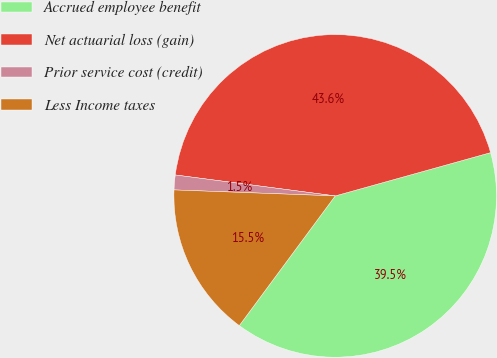Convert chart. <chart><loc_0><loc_0><loc_500><loc_500><pie_chart><fcel>Accrued employee benefit<fcel>Net actuarial loss (gain)<fcel>Prior service cost (credit)<fcel>Less Income taxes<nl><fcel>39.46%<fcel>43.6%<fcel>1.48%<fcel>15.46%<nl></chart> 